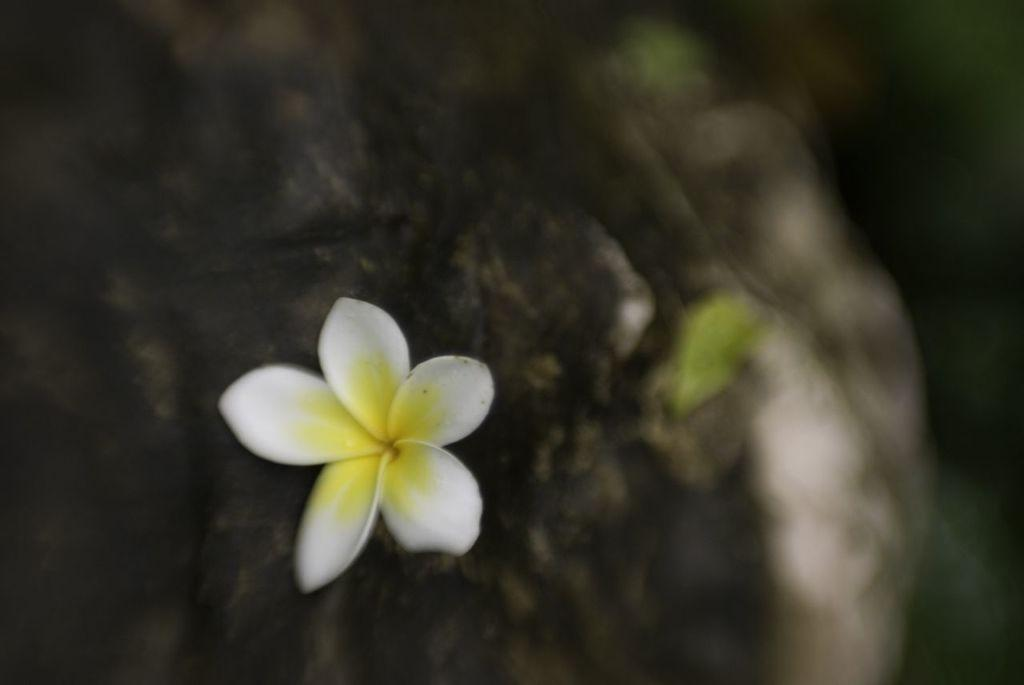What is the main subject of the image? There is a flower in the image. Can you describe the colors of the flower? The flower has white and yellow colors. How would you describe the background of the image? The background of the image is blurry. What colors are present in the background? The background colors include green, black, and white. What type of gate is present in the image? There is no gate present in the image; it features a flower with a blurry background. How does the flower relate to the background colors? The flower and the background colors are separate elements in the image and do not have a direct relation. 